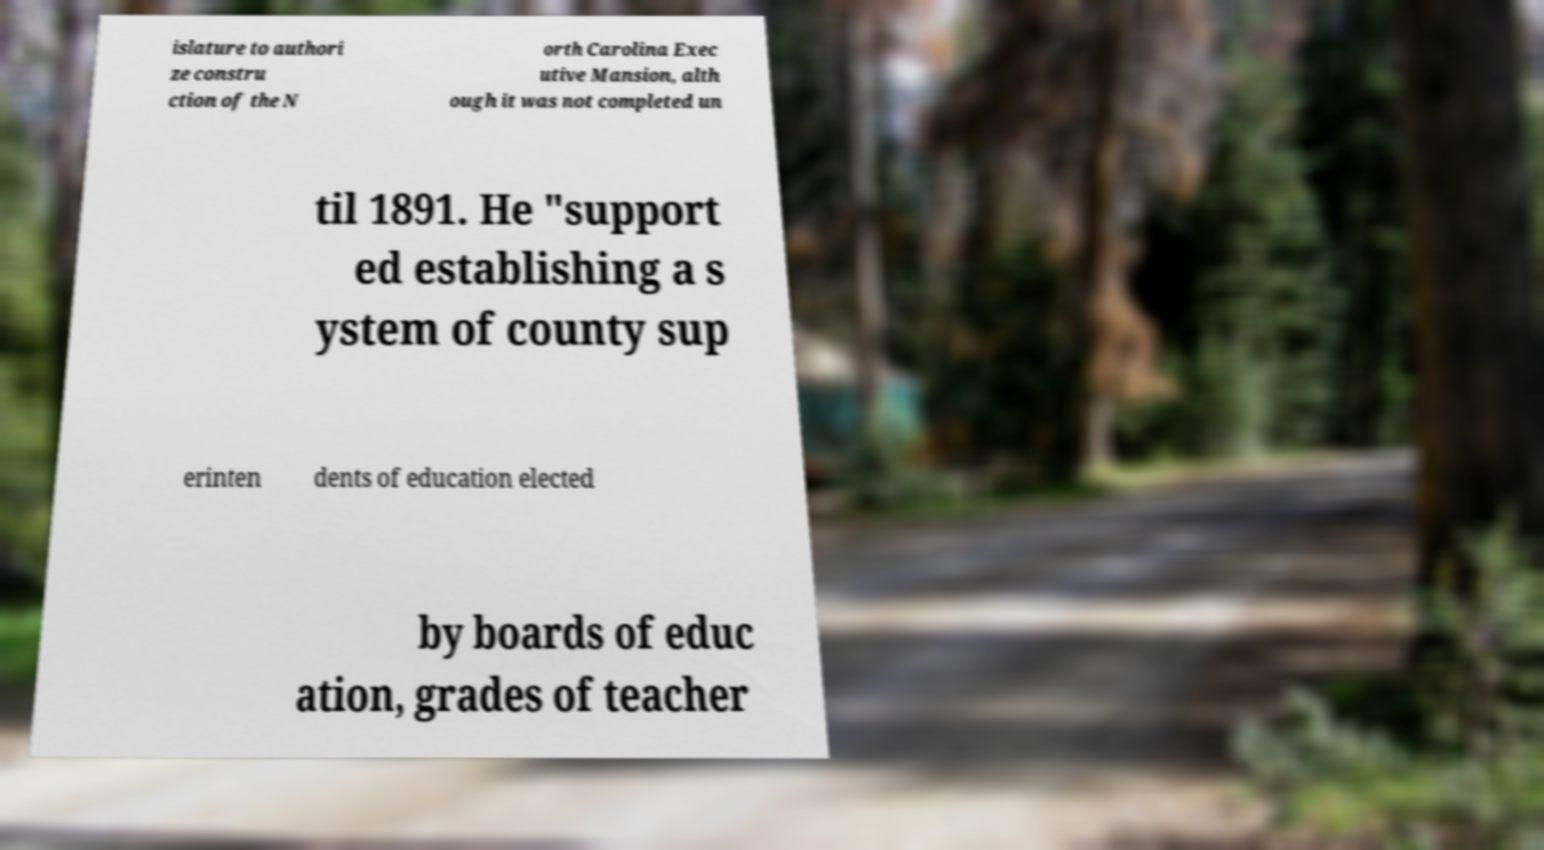Can you accurately transcribe the text from the provided image for me? islature to authori ze constru ction of the N orth Carolina Exec utive Mansion, alth ough it was not completed un til 1891. He "support ed establishing a s ystem of county sup erinten dents of education elected by boards of educ ation, grades of teacher 